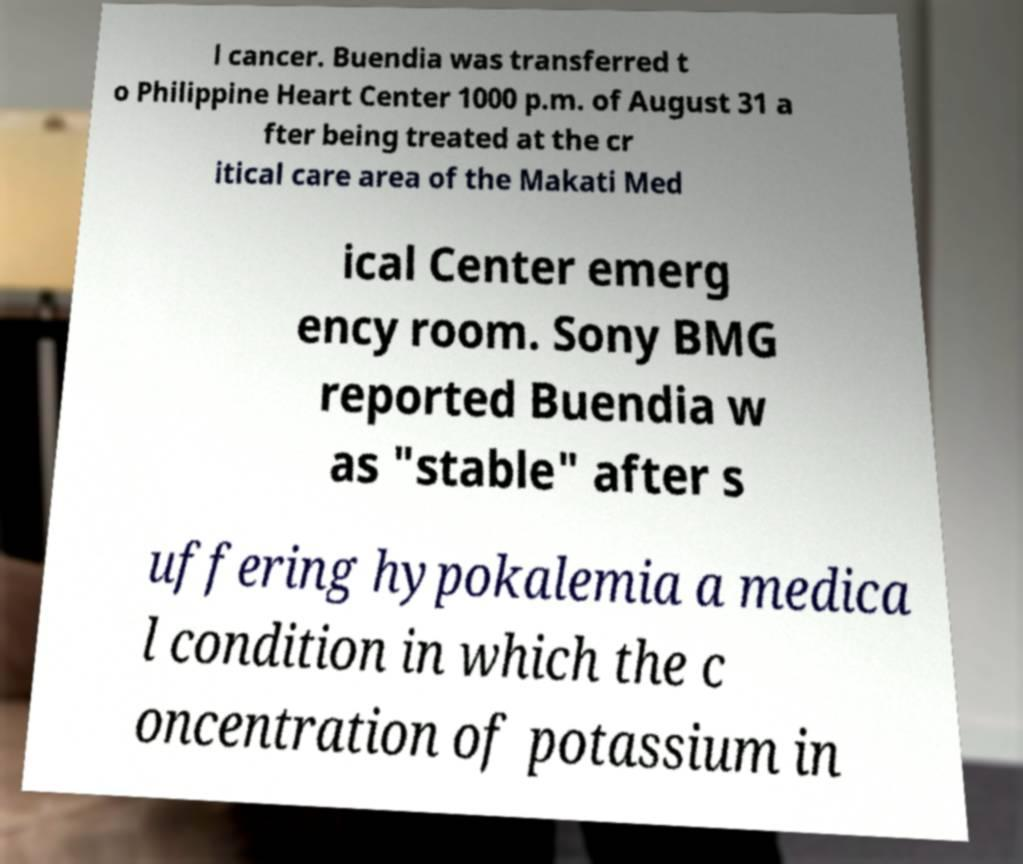Could you assist in decoding the text presented in this image and type it out clearly? l cancer. Buendia was transferred t o Philippine Heart Center 1000 p.m. of August 31 a fter being treated at the cr itical care area of the Makati Med ical Center emerg ency room. Sony BMG reported Buendia w as "stable" after s uffering hypokalemia a medica l condition in which the c oncentration of potassium in 